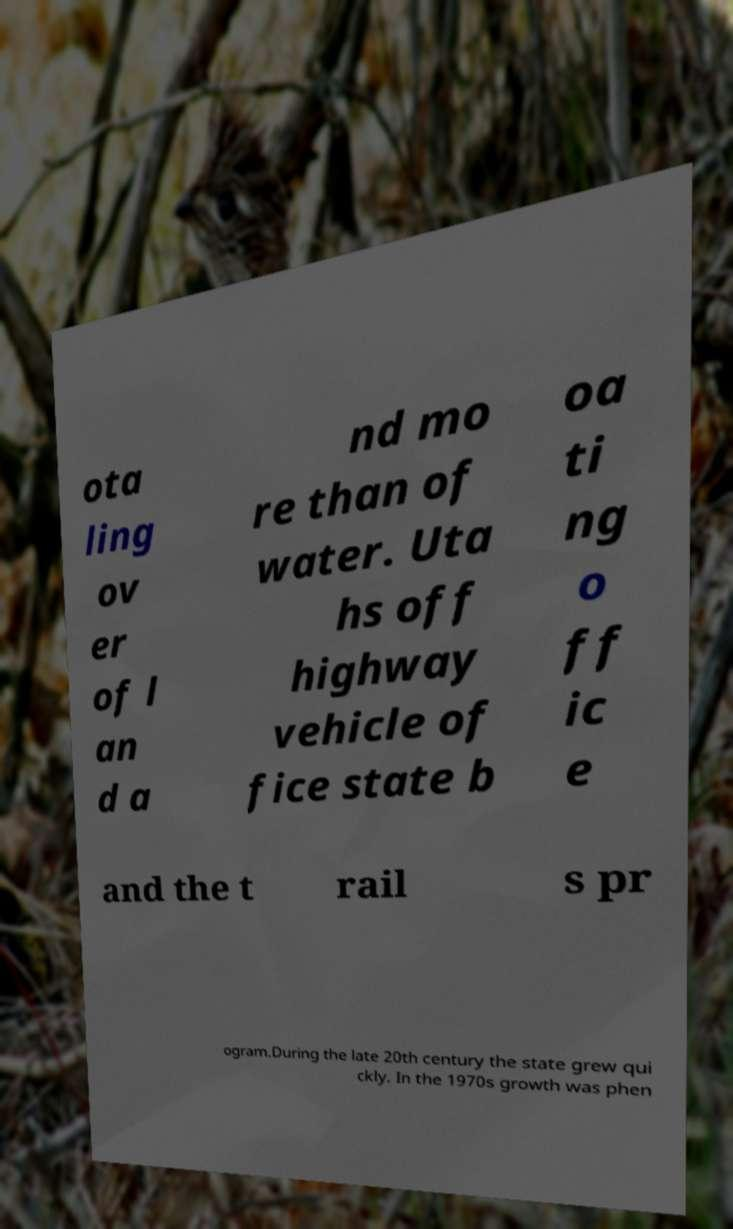Could you assist in decoding the text presented in this image and type it out clearly? ota ling ov er of l an d a nd mo re than of water. Uta hs off highway vehicle of fice state b oa ti ng o ff ic e and the t rail s pr ogram.During the late 20th century the state grew qui ckly. In the 1970s growth was phen 